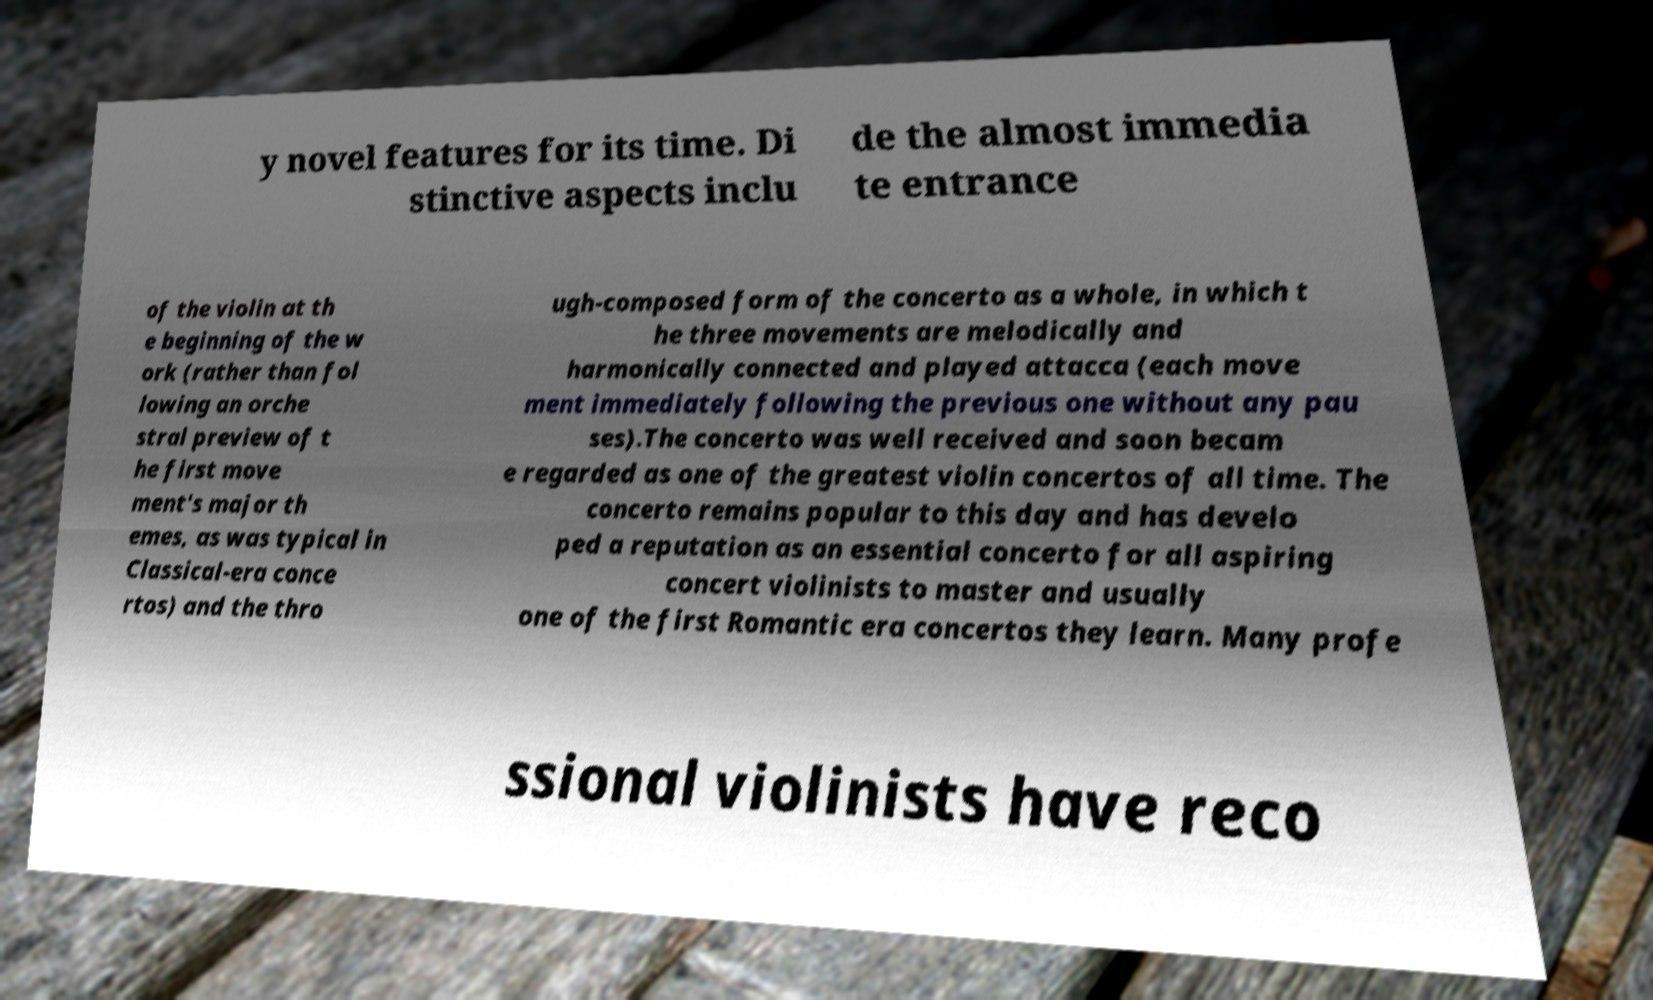I need the written content from this picture converted into text. Can you do that? y novel features for its time. Di stinctive aspects inclu de the almost immedia te entrance of the violin at th e beginning of the w ork (rather than fol lowing an orche stral preview of t he first move ment's major th emes, as was typical in Classical-era conce rtos) and the thro ugh-composed form of the concerto as a whole, in which t he three movements are melodically and harmonically connected and played attacca (each move ment immediately following the previous one without any pau ses).The concerto was well received and soon becam e regarded as one of the greatest violin concertos of all time. The concerto remains popular to this day and has develo ped a reputation as an essential concerto for all aspiring concert violinists to master and usually one of the first Romantic era concertos they learn. Many profe ssional violinists have reco 